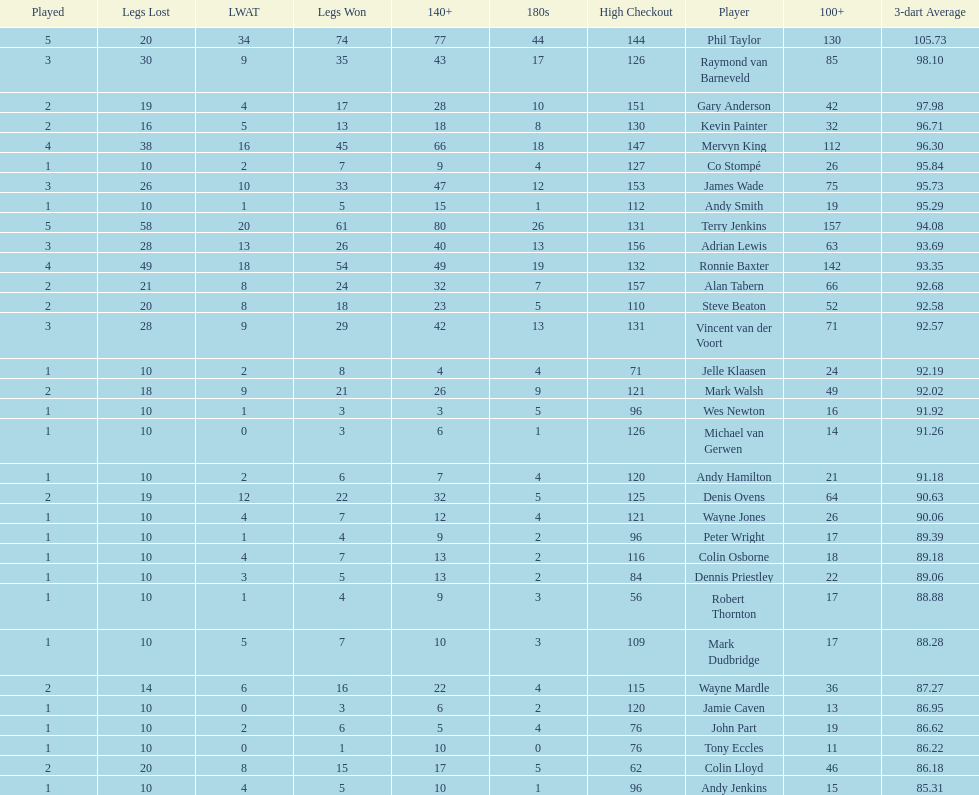Who won the highest number of legs in the 2009 world matchplay? Phil Taylor. 